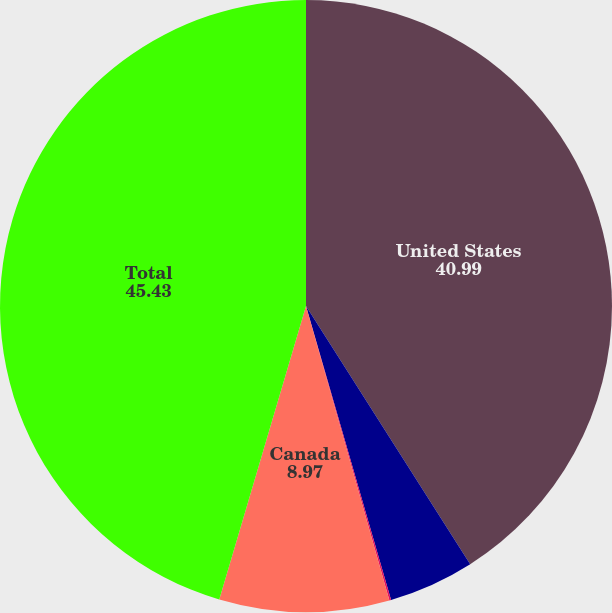<chart> <loc_0><loc_0><loc_500><loc_500><pie_chart><fcel>United States<fcel>Trinidad<fcel>United Kingdom<fcel>Canada<fcel>Total<nl><fcel>40.99%<fcel>4.53%<fcel>0.09%<fcel>8.97%<fcel>45.43%<nl></chart> 